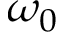Convert formula to latex. <formula><loc_0><loc_0><loc_500><loc_500>\omega _ { 0 }</formula> 